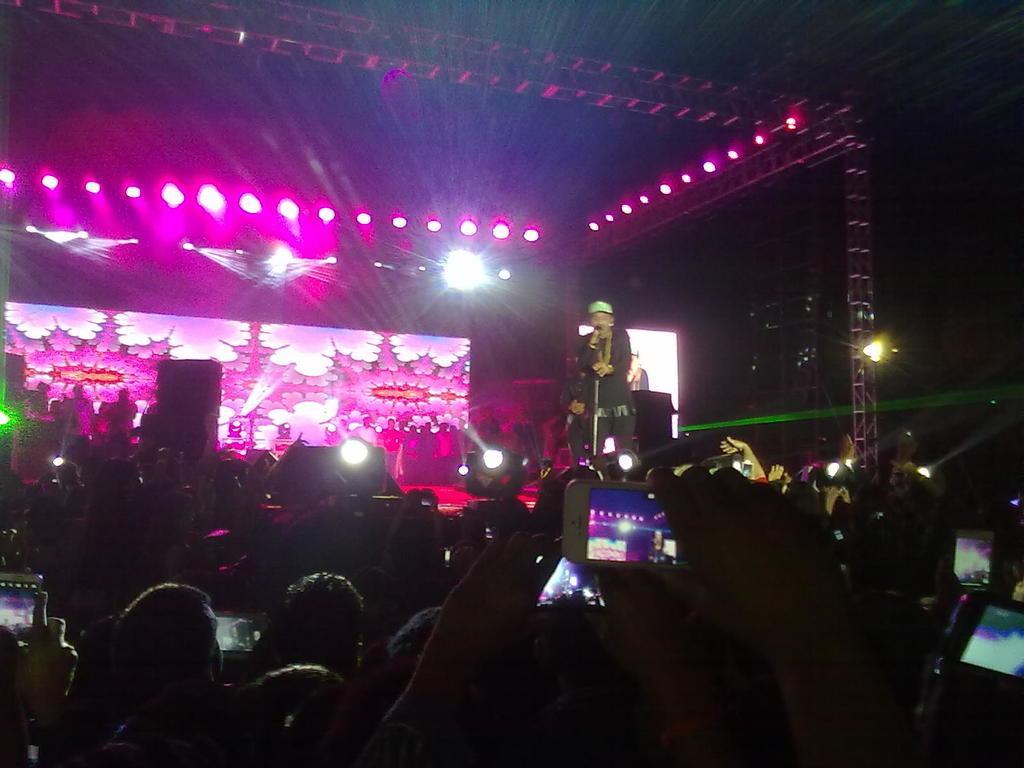How would you summarize this image in a sentence or two? In this image it looks like a music concert. In the middle there is a stage on which there is a person singing with the mic. At the top there are lights. In the background there is a screen At the bottom there are so many spectators who are taking the pictures with the phones. 